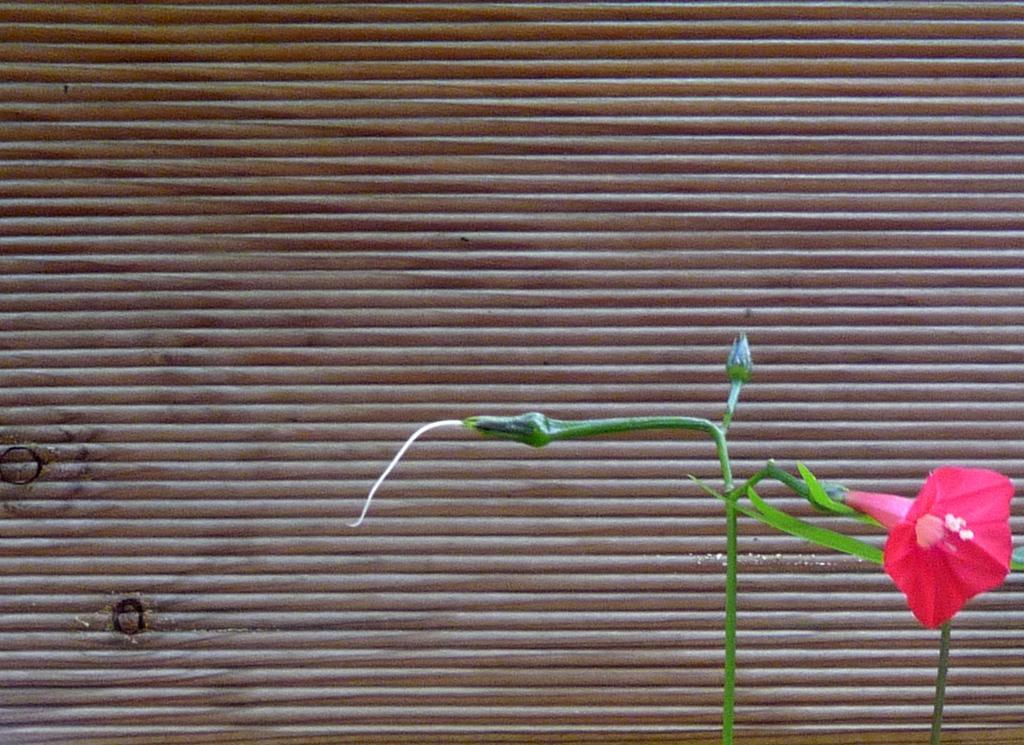In one or two sentences, can you explain what this image depicts? In this image we can see a plant and there is a flower. Which is in pink color. We can see buds. In the background we can see blinds. 